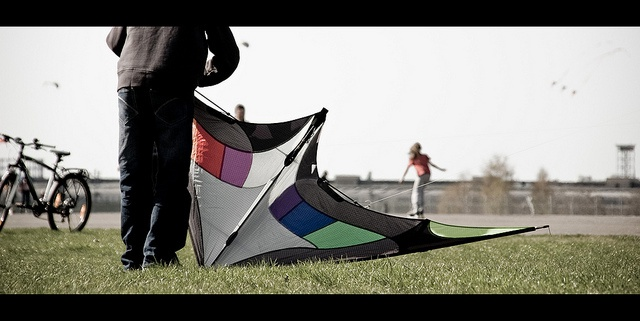Describe the objects in this image and their specific colors. I can see kite in black, gray, darkgray, and lightgray tones, people in black, gray, darkgray, and lightgray tones, bicycle in black, gray, darkgray, and lightgray tones, people in black, gray, lightgray, darkgray, and maroon tones, and kite in darkgray, lightgray, gray, and black tones in this image. 